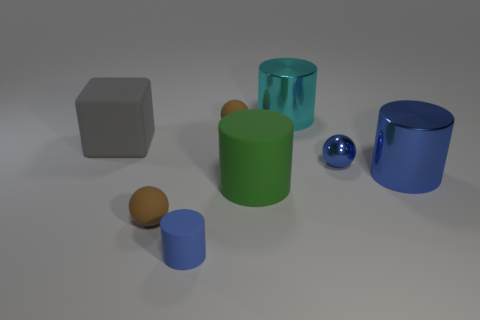Add 1 large matte things. How many objects exist? 9 Subtract all cubes. How many objects are left? 7 Add 1 tiny rubber spheres. How many tiny rubber spheres are left? 3 Add 1 small brown objects. How many small brown objects exist? 3 Subtract 0 cyan balls. How many objects are left? 8 Subtract all blue shiny cylinders. Subtract all shiny cylinders. How many objects are left? 5 